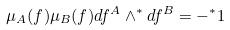<formula> <loc_0><loc_0><loc_500><loc_500>\mu _ { A } ( f ) \mu _ { B } ( f ) d f ^ { A } \wedge ^ { * } d f ^ { B } = - ^ { * } 1</formula> 